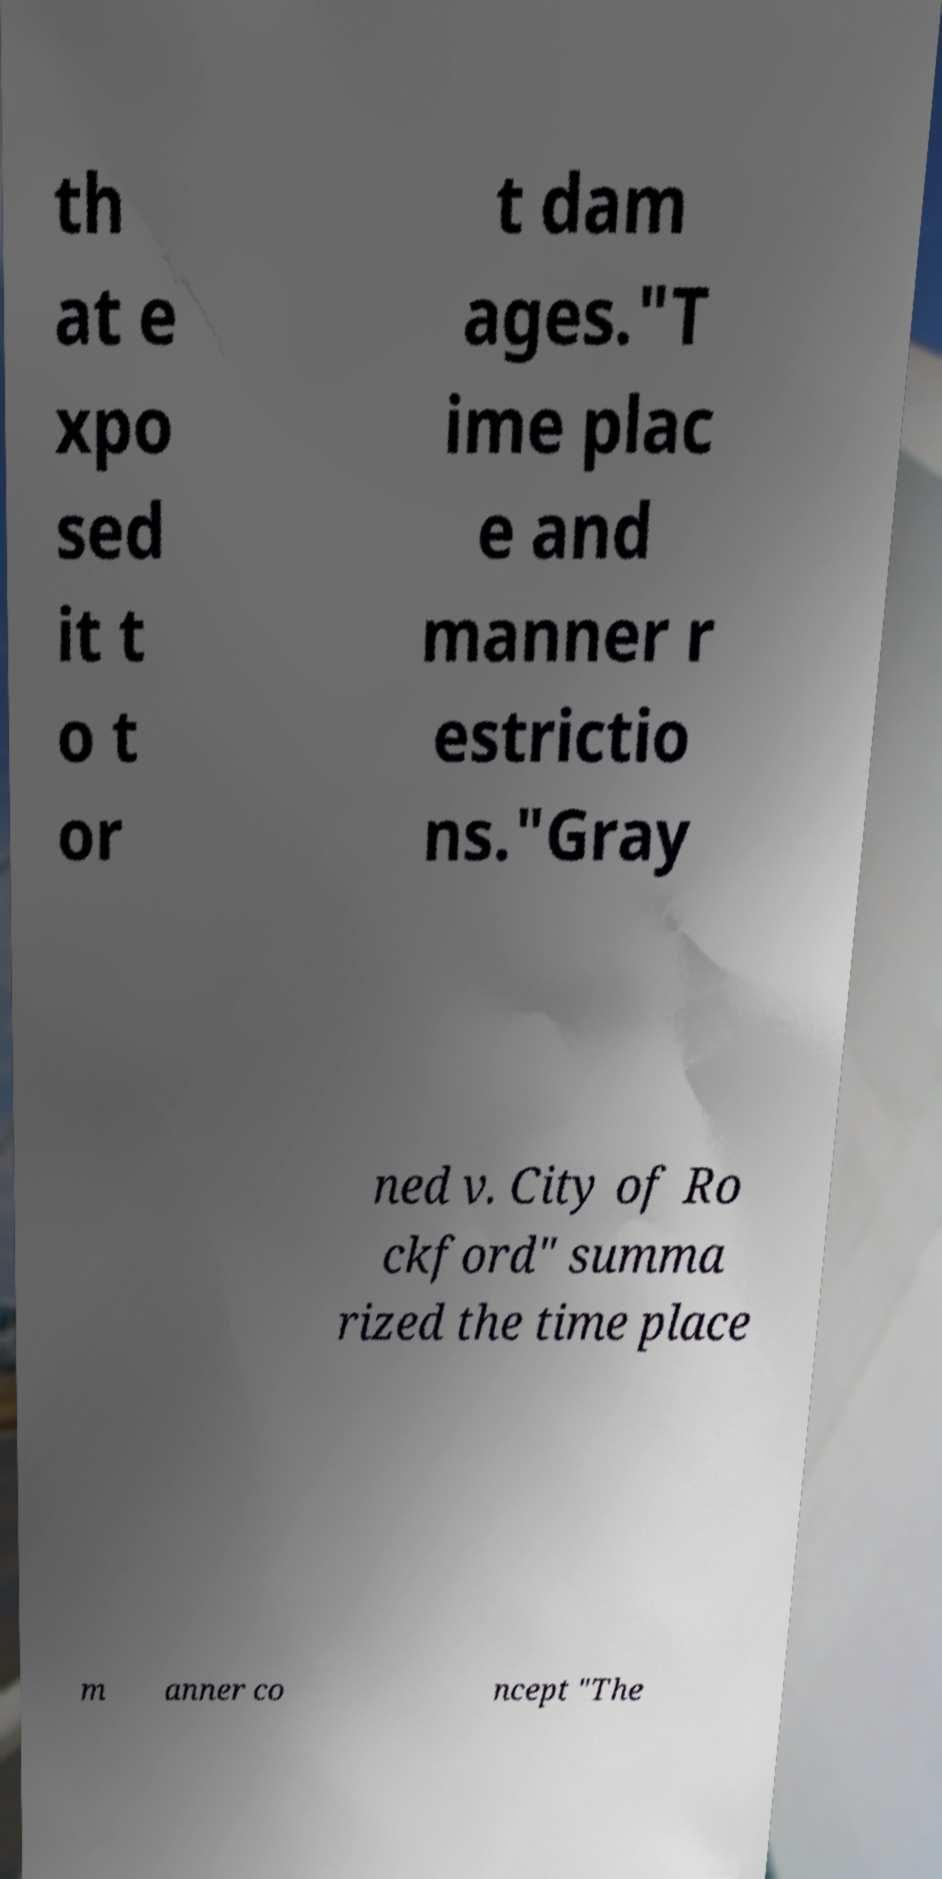I need the written content from this picture converted into text. Can you do that? th at e xpo sed it t o t or t dam ages."T ime plac e and manner r estrictio ns."Gray ned v. City of Ro ckford" summa rized the time place m anner co ncept "The 